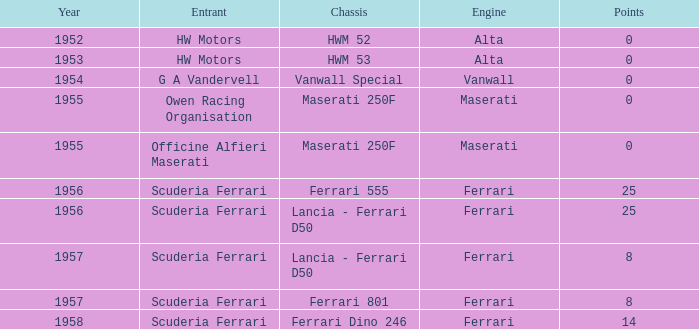What corporation produced the chassis when ferrari manufactured the engine and there were 25 points? Ferrari 555, Lancia - Ferrari D50. 